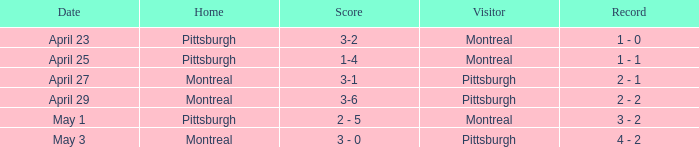When did Montreal visit and have a score of 1-4? April 25. 